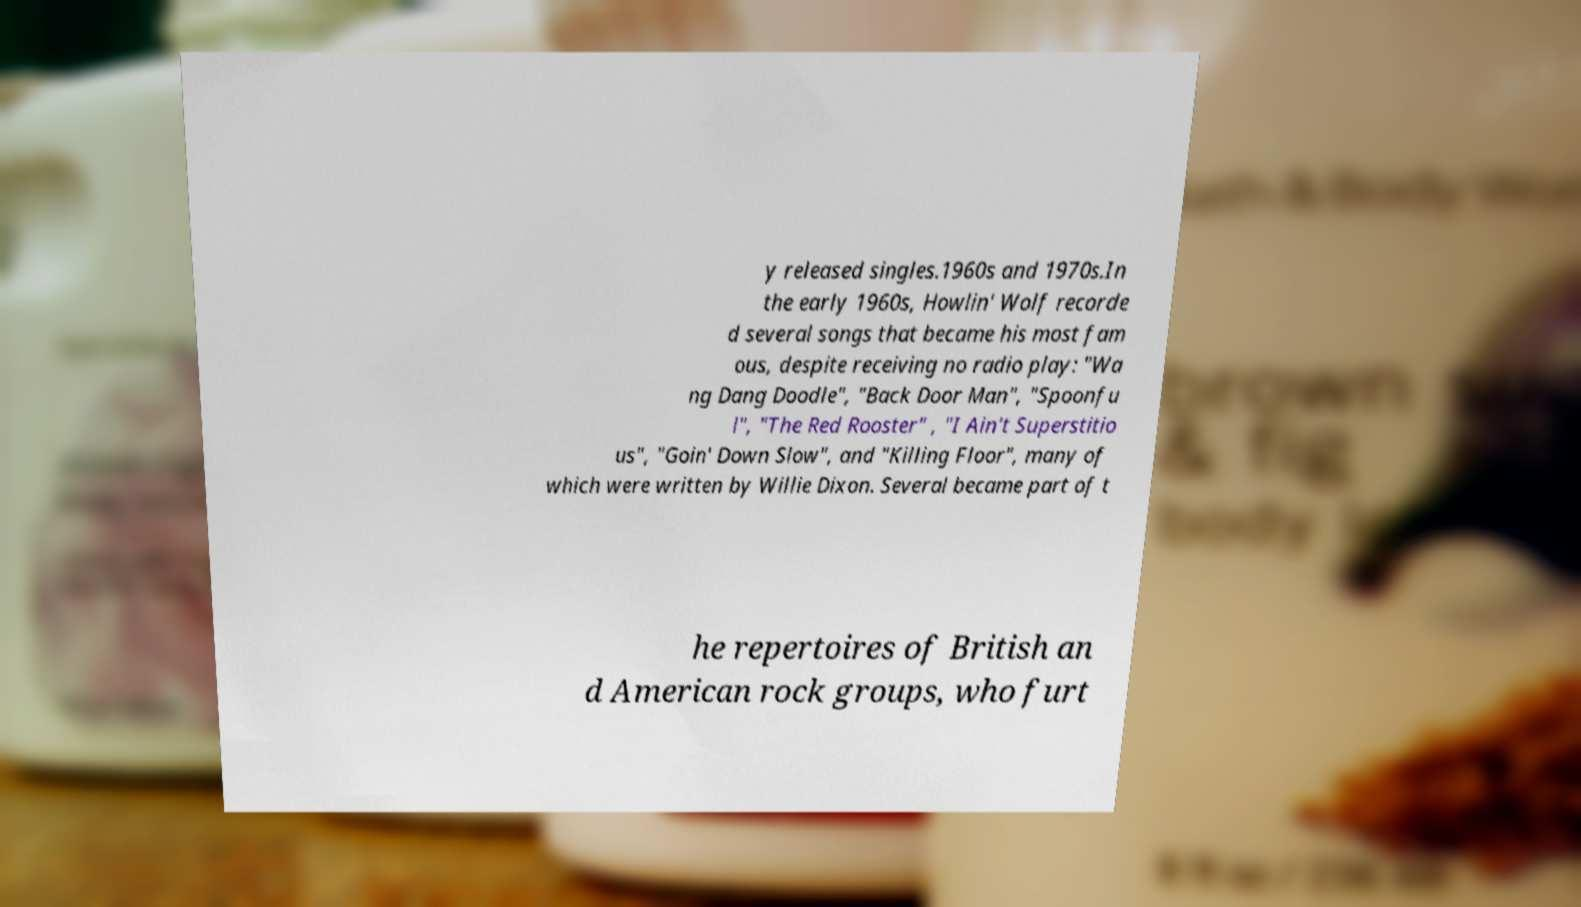Could you assist in decoding the text presented in this image and type it out clearly? y released singles.1960s and 1970s.In the early 1960s, Howlin' Wolf recorde d several songs that became his most fam ous, despite receiving no radio play: "Wa ng Dang Doodle", "Back Door Man", "Spoonfu l", "The Red Rooster" , "I Ain't Superstitio us", "Goin' Down Slow", and "Killing Floor", many of which were written by Willie Dixon. Several became part of t he repertoires of British an d American rock groups, who furt 